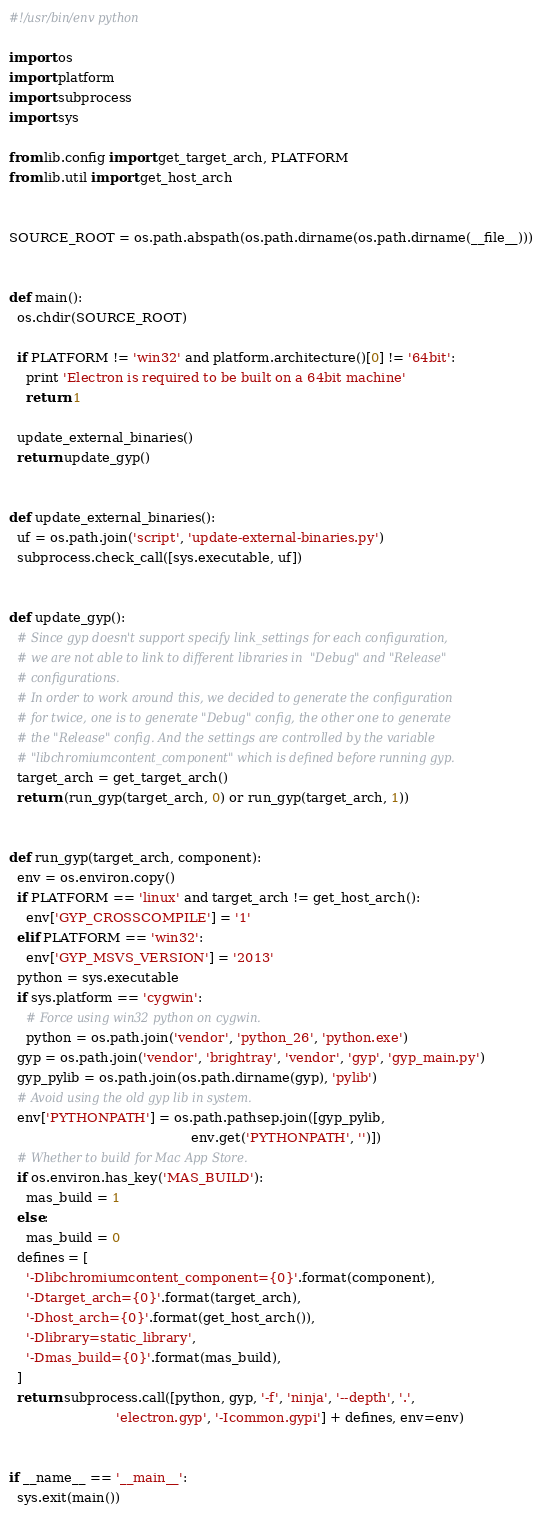<code> <loc_0><loc_0><loc_500><loc_500><_Python_>#!/usr/bin/env python

import os
import platform
import subprocess
import sys

from lib.config import get_target_arch, PLATFORM
from lib.util import get_host_arch


SOURCE_ROOT = os.path.abspath(os.path.dirname(os.path.dirname(__file__)))


def main():
  os.chdir(SOURCE_ROOT)

  if PLATFORM != 'win32' and platform.architecture()[0] != '64bit':
    print 'Electron is required to be built on a 64bit machine'
    return 1

  update_external_binaries()
  return update_gyp()


def update_external_binaries():
  uf = os.path.join('script', 'update-external-binaries.py')
  subprocess.check_call([sys.executable, uf])


def update_gyp():
  # Since gyp doesn't support specify link_settings for each configuration,
  # we are not able to link to different libraries in  "Debug" and "Release"
  # configurations.
  # In order to work around this, we decided to generate the configuration
  # for twice, one is to generate "Debug" config, the other one to generate
  # the "Release" config. And the settings are controlled by the variable
  # "libchromiumcontent_component" which is defined before running gyp.
  target_arch = get_target_arch()
  return (run_gyp(target_arch, 0) or run_gyp(target_arch, 1))


def run_gyp(target_arch, component):
  env = os.environ.copy()
  if PLATFORM == 'linux' and target_arch != get_host_arch():
    env['GYP_CROSSCOMPILE'] = '1'
  elif PLATFORM == 'win32':
    env['GYP_MSVS_VERSION'] = '2013'
  python = sys.executable
  if sys.platform == 'cygwin':
    # Force using win32 python on cygwin.
    python = os.path.join('vendor', 'python_26', 'python.exe')
  gyp = os.path.join('vendor', 'brightray', 'vendor', 'gyp', 'gyp_main.py')
  gyp_pylib = os.path.join(os.path.dirname(gyp), 'pylib')
  # Avoid using the old gyp lib in system.
  env['PYTHONPATH'] = os.path.pathsep.join([gyp_pylib,
                                            env.get('PYTHONPATH', '')])
  # Whether to build for Mac App Store.
  if os.environ.has_key('MAS_BUILD'):
    mas_build = 1
  else:
    mas_build = 0
  defines = [
    '-Dlibchromiumcontent_component={0}'.format(component),
    '-Dtarget_arch={0}'.format(target_arch),
    '-Dhost_arch={0}'.format(get_host_arch()),
    '-Dlibrary=static_library',
    '-Dmas_build={0}'.format(mas_build),
  ]
  return subprocess.call([python, gyp, '-f', 'ninja', '--depth', '.',
                          'electron.gyp', '-Icommon.gypi'] + defines, env=env)


if __name__ == '__main__':
  sys.exit(main())
</code> 